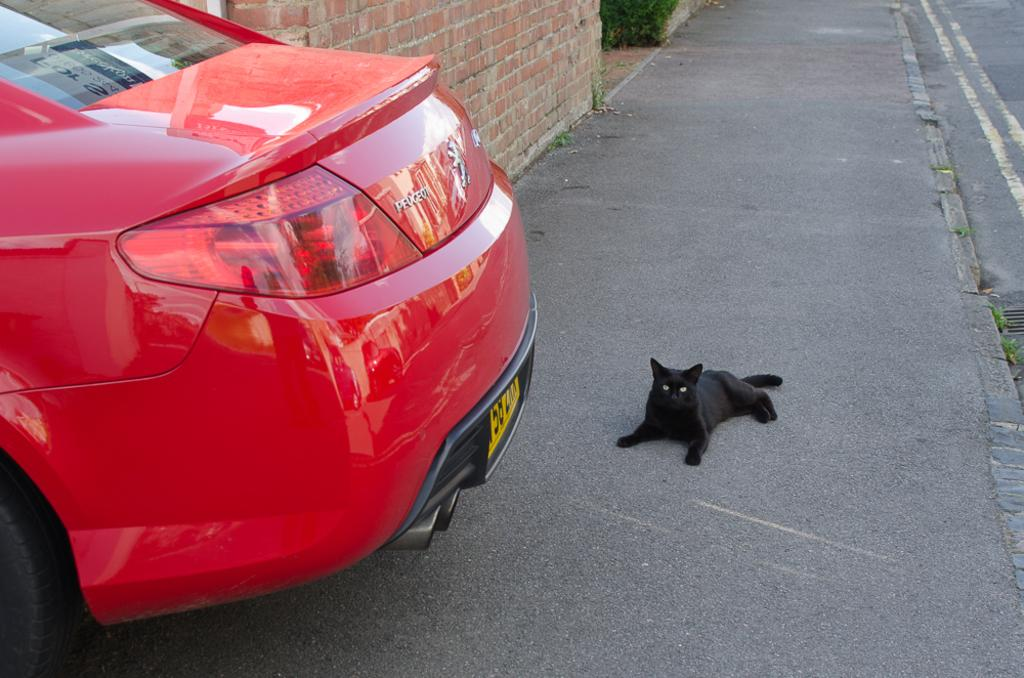What animal can be seen laying on the footpath in the image? There is a cat laying on a footpath in the image. What type of vehicle is on the left side of the image? There is a car on the left side of the image. What is behind the car in the image? There is a wall behind the car in the image. What type of waves can be seen crashing on the shore in the image? There are no waves or shore present in the image; it features a cat laying on a footpath and a car on the left side with a wall behind it. 